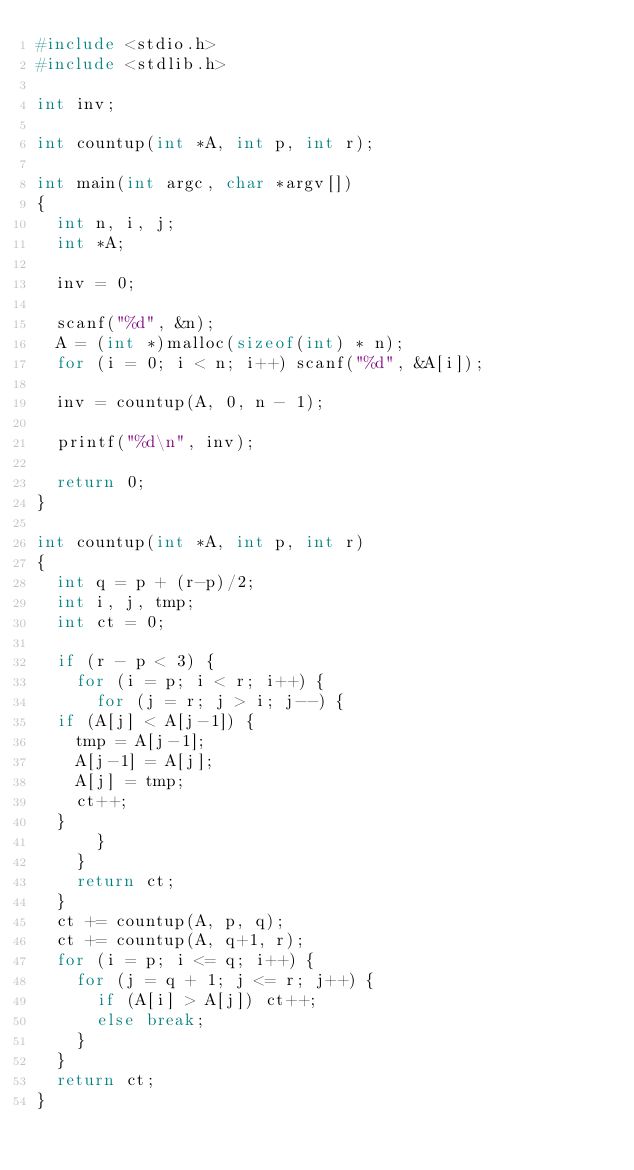<code> <loc_0><loc_0><loc_500><loc_500><_C_>#include <stdio.h>
#include <stdlib.h>

int inv;

int countup(int *A, int p, int r);

int main(int argc, char *argv[])
{
  int n, i, j;
  int *A;

  inv = 0;

  scanf("%d", &n);
  A = (int *)malloc(sizeof(int) * n);
  for (i = 0; i < n; i++) scanf("%d", &A[i]);

  inv = countup(A, 0, n - 1);

  printf("%d\n", inv);

  return 0;
}

int countup(int *A, int p, int r)
{
  int q = p + (r-p)/2;
  int i, j, tmp;
  int ct = 0;

  if (r - p < 3) {
    for (i = p; i < r; i++) {
      for (j = r; j > i; j--) {
	if (A[j] < A[j-1]) {
	  tmp = A[j-1];
	  A[j-1] = A[j];
	  A[j] = tmp;
	  ct++;
	}
      }
    }
    return ct;
  }
  ct += countup(A, p, q);
  ct += countup(A, q+1, r);
  for (i = p; i <= q; i++) {
    for (j = q + 1; j <= r; j++) {
      if (A[i] > A[j]) ct++;
      else break;
    }
  }
  return ct;
}</code> 